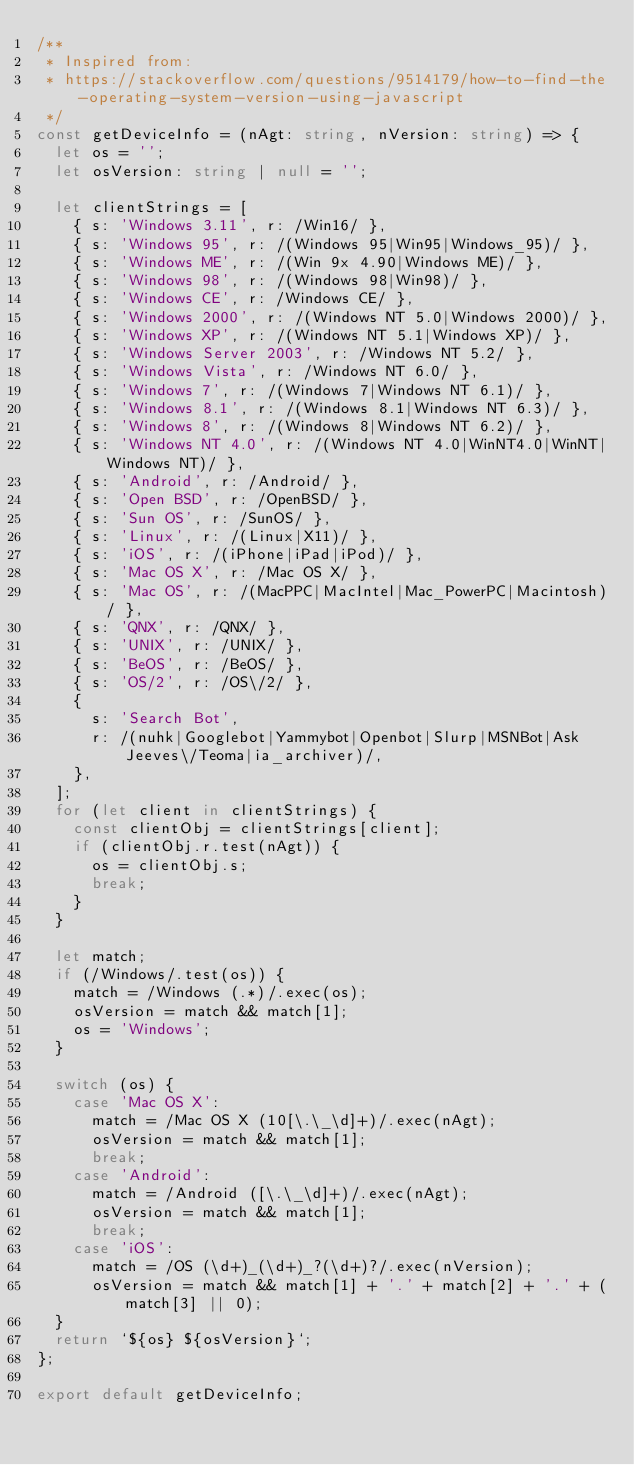Convert code to text. <code><loc_0><loc_0><loc_500><loc_500><_TypeScript_>/**
 * Inspired from:
 * https://stackoverflow.com/questions/9514179/how-to-find-the-operating-system-version-using-javascript
 */
const getDeviceInfo = (nAgt: string, nVersion: string) => {
  let os = '';
  let osVersion: string | null = '';

  let clientStrings = [
    { s: 'Windows 3.11', r: /Win16/ },
    { s: 'Windows 95', r: /(Windows 95|Win95|Windows_95)/ },
    { s: 'Windows ME', r: /(Win 9x 4.90|Windows ME)/ },
    { s: 'Windows 98', r: /(Windows 98|Win98)/ },
    { s: 'Windows CE', r: /Windows CE/ },
    { s: 'Windows 2000', r: /(Windows NT 5.0|Windows 2000)/ },
    { s: 'Windows XP', r: /(Windows NT 5.1|Windows XP)/ },
    { s: 'Windows Server 2003', r: /Windows NT 5.2/ },
    { s: 'Windows Vista', r: /Windows NT 6.0/ },
    { s: 'Windows 7', r: /(Windows 7|Windows NT 6.1)/ },
    { s: 'Windows 8.1', r: /(Windows 8.1|Windows NT 6.3)/ },
    { s: 'Windows 8', r: /(Windows 8|Windows NT 6.2)/ },
    { s: 'Windows NT 4.0', r: /(Windows NT 4.0|WinNT4.0|WinNT|Windows NT)/ },
    { s: 'Android', r: /Android/ },
    { s: 'Open BSD', r: /OpenBSD/ },
    { s: 'Sun OS', r: /SunOS/ },
    { s: 'Linux', r: /(Linux|X11)/ },
    { s: 'iOS', r: /(iPhone|iPad|iPod)/ },
    { s: 'Mac OS X', r: /Mac OS X/ },
    { s: 'Mac OS', r: /(MacPPC|MacIntel|Mac_PowerPC|Macintosh)/ },
    { s: 'QNX', r: /QNX/ },
    { s: 'UNIX', r: /UNIX/ },
    { s: 'BeOS', r: /BeOS/ },
    { s: 'OS/2', r: /OS\/2/ },
    {
      s: 'Search Bot',
      r: /(nuhk|Googlebot|Yammybot|Openbot|Slurp|MSNBot|Ask Jeeves\/Teoma|ia_archiver)/,
    },
  ];
  for (let client in clientStrings) {
    const clientObj = clientStrings[client];
    if (clientObj.r.test(nAgt)) {
      os = clientObj.s;
      break;
    }
  }

  let match;
  if (/Windows/.test(os)) {
    match = /Windows (.*)/.exec(os);
    osVersion = match && match[1];
    os = 'Windows';
  }

  switch (os) {
    case 'Mac OS X':
      match = /Mac OS X (10[\.\_\d]+)/.exec(nAgt);
      osVersion = match && match[1];
      break;
    case 'Android':
      match = /Android ([\.\_\d]+)/.exec(nAgt);
      osVersion = match && match[1];
      break;
    case 'iOS':
      match = /OS (\d+)_(\d+)_?(\d+)?/.exec(nVersion);
      osVersion = match && match[1] + '.' + match[2] + '.' + (match[3] || 0);
  }
  return `${os} ${osVersion}`;
};

export default getDeviceInfo;
</code> 